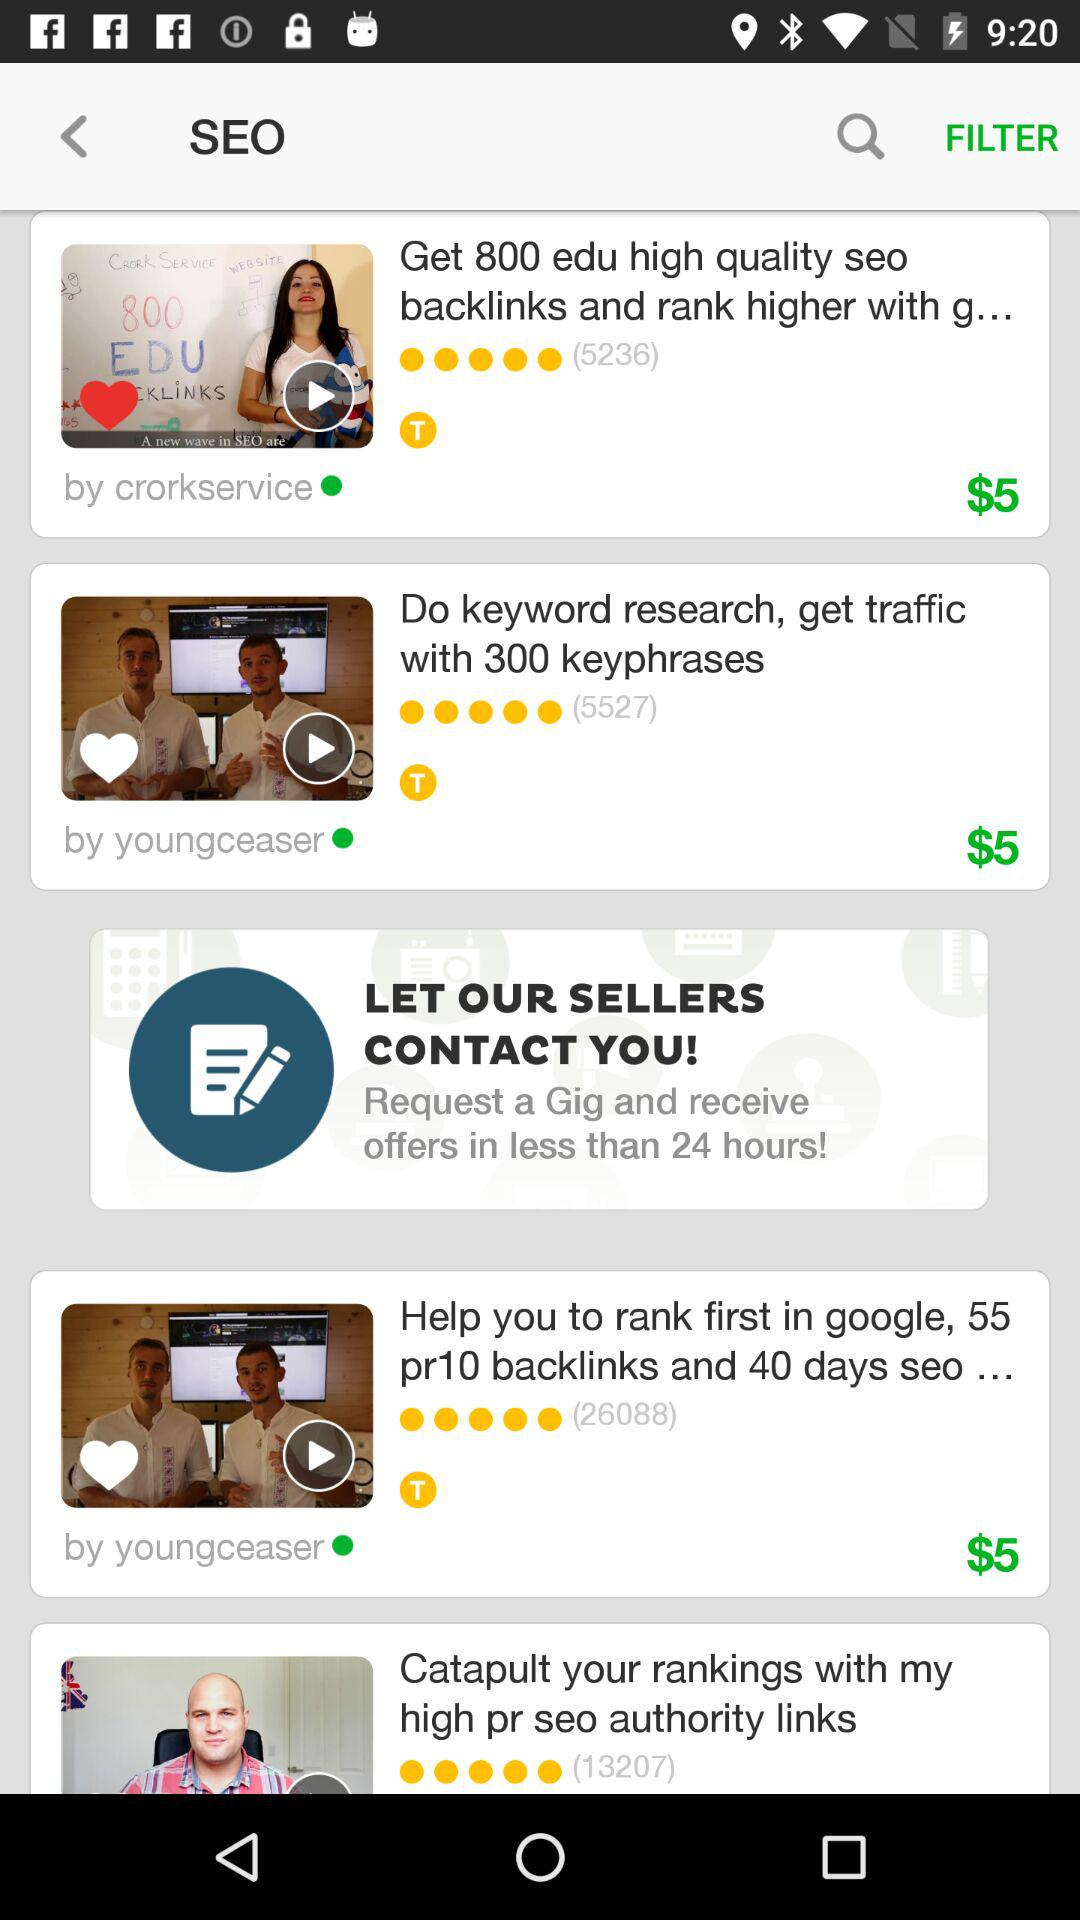What is the cost of the video made by "crorkservice"? The cost is $5. 